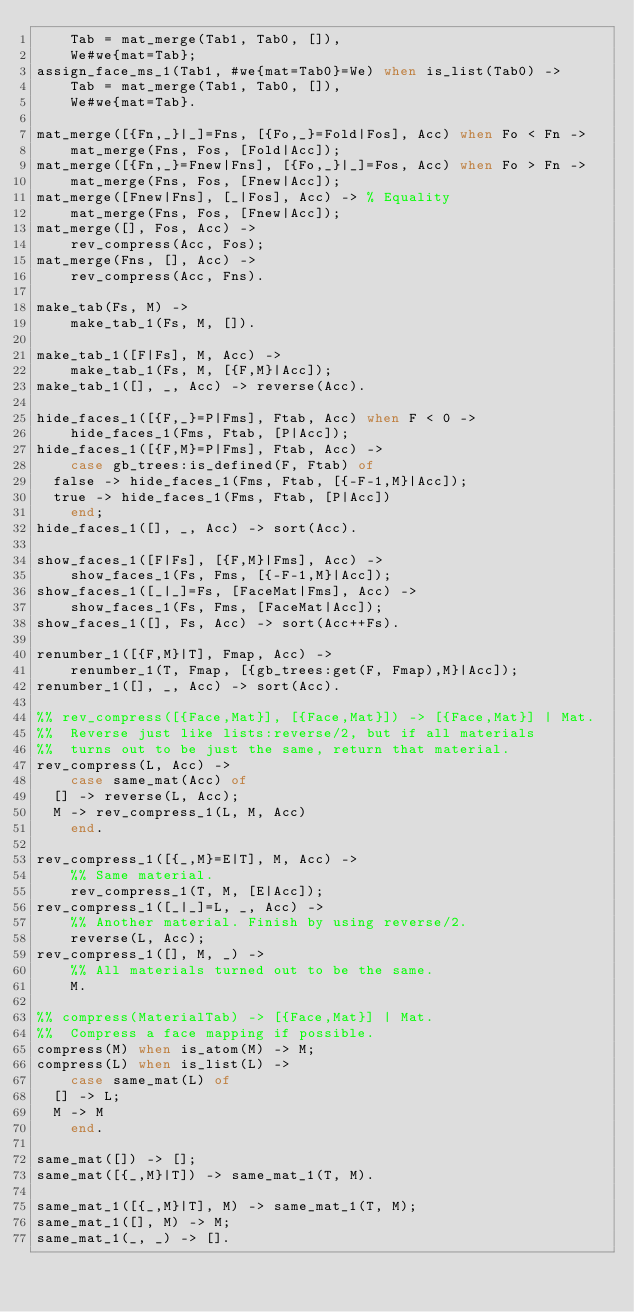Convert code to text. <code><loc_0><loc_0><loc_500><loc_500><_Erlang_>    Tab = mat_merge(Tab1, Tab0, []),
    We#we{mat=Tab};
assign_face_ms_1(Tab1, #we{mat=Tab0}=We) when is_list(Tab0) ->
    Tab = mat_merge(Tab1, Tab0, []),
    We#we{mat=Tab}.

mat_merge([{Fn,_}|_]=Fns, [{Fo,_}=Fold|Fos], Acc) when Fo < Fn ->
    mat_merge(Fns, Fos, [Fold|Acc]);
mat_merge([{Fn,_}=Fnew|Fns], [{Fo,_}|_]=Fos, Acc) when Fo > Fn ->
    mat_merge(Fns, Fos, [Fnew|Acc]);
mat_merge([Fnew|Fns], [_|Fos], Acc) -> % Equality
    mat_merge(Fns, Fos, [Fnew|Acc]);
mat_merge([], Fos, Acc) ->
    rev_compress(Acc, Fos);
mat_merge(Fns, [], Acc) ->
    rev_compress(Acc, Fns).

make_tab(Fs, M) ->
    make_tab_1(Fs, M, []).

make_tab_1([F|Fs], M, Acc) ->
    make_tab_1(Fs, M, [{F,M}|Acc]);
make_tab_1([], _, Acc) -> reverse(Acc).

hide_faces_1([{F,_}=P|Fms], Ftab, Acc) when F < 0 ->
    hide_faces_1(Fms, Ftab, [P|Acc]);
hide_faces_1([{F,M}=P|Fms], Ftab, Acc) ->
    case gb_trees:is_defined(F, Ftab) of
	false -> hide_faces_1(Fms, Ftab, [{-F-1,M}|Acc]);
	true -> hide_faces_1(Fms, Ftab, [P|Acc])
    end;
hide_faces_1([], _, Acc) -> sort(Acc).

show_faces_1([F|Fs], [{F,M}|Fms], Acc) ->
    show_faces_1(Fs, Fms, [{-F-1,M}|Acc]);
show_faces_1([_|_]=Fs, [FaceMat|Fms], Acc) ->
    show_faces_1(Fs, Fms, [FaceMat|Acc]);
show_faces_1([], Fs, Acc) -> sort(Acc++Fs).

renumber_1([{F,M}|T], Fmap, Acc) ->
    renumber_1(T, Fmap, [{gb_trees:get(F, Fmap),M}|Acc]);
renumber_1([], _, Acc) -> sort(Acc).

%% rev_compress([{Face,Mat}], [{Face,Mat}]) -> [{Face,Mat}] | Mat.
%%  Reverse just like lists:reverse/2, but if all materials
%%  turns out to be just the same, return that material.
rev_compress(L, Acc) ->
    case same_mat(Acc) of
	[] -> reverse(L, Acc);
	M -> rev_compress_1(L, M, Acc)
    end.

rev_compress_1([{_,M}=E|T], M, Acc) ->
    %% Same material.
    rev_compress_1(T, M, [E|Acc]);
rev_compress_1([_|_]=L, _, Acc) ->
    %% Another material. Finish by using reverse/2.
    reverse(L, Acc);
rev_compress_1([], M, _) ->
    %% All materials turned out to be the same.
    M.

%% compress(MaterialTab) -> [{Face,Mat}] | Mat.
%%  Compress a face mapping if possible.
compress(M) when is_atom(M) -> M;
compress(L) when is_list(L) ->
    case same_mat(L) of
	[] -> L;
	M -> M
    end.

same_mat([]) -> [];
same_mat([{_,M}|T]) -> same_mat_1(T, M).

same_mat_1([{_,M}|T], M) -> same_mat_1(T, M);
same_mat_1([], M) -> M;
same_mat_1(_, _) -> [].
</code> 